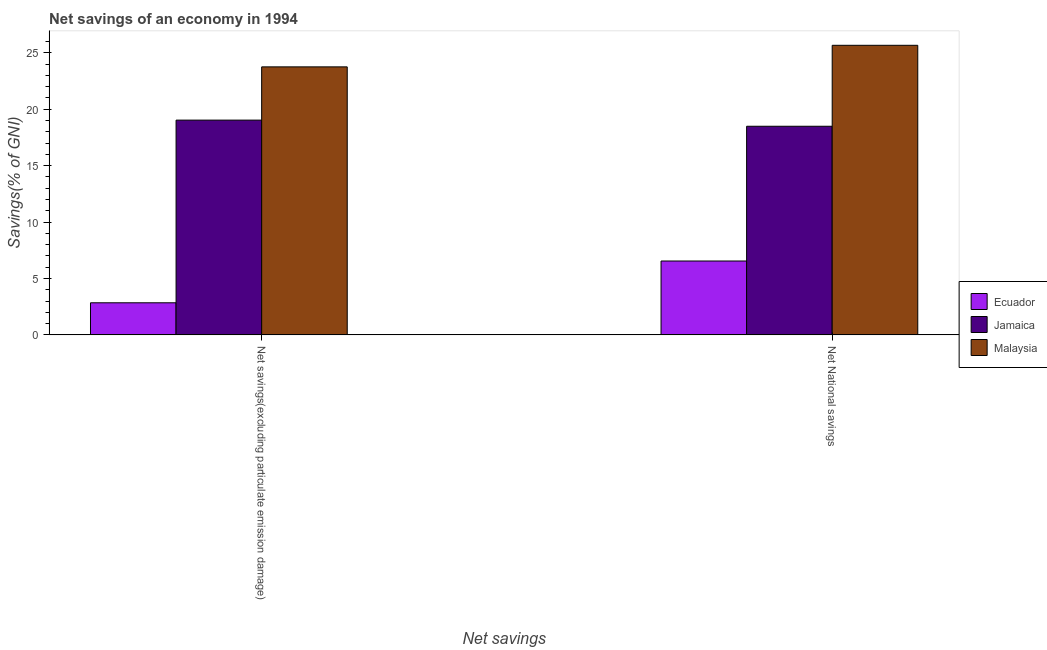How many bars are there on the 1st tick from the right?
Ensure brevity in your answer.  3. What is the label of the 1st group of bars from the left?
Your answer should be very brief. Net savings(excluding particulate emission damage). What is the net savings(excluding particulate emission damage) in Malaysia?
Make the answer very short. 23.76. Across all countries, what is the maximum net savings(excluding particulate emission damage)?
Keep it short and to the point. 23.76. Across all countries, what is the minimum net national savings?
Make the answer very short. 6.55. In which country was the net savings(excluding particulate emission damage) maximum?
Your response must be concise. Malaysia. In which country was the net savings(excluding particulate emission damage) minimum?
Keep it short and to the point. Ecuador. What is the total net national savings in the graph?
Offer a terse response. 50.71. What is the difference between the net savings(excluding particulate emission damage) in Ecuador and that in Malaysia?
Keep it short and to the point. -20.91. What is the difference between the net savings(excluding particulate emission damage) in Ecuador and the net national savings in Jamaica?
Provide a succinct answer. -15.65. What is the average net savings(excluding particulate emission damage) per country?
Offer a very short reply. 15.21. What is the difference between the net savings(excluding particulate emission damage) and net national savings in Ecuador?
Give a very brief answer. -3.7. In how many countries, is the net savings(excluding particulate emission damage) greater than 15 %?
Keep it short and to the point. 2. What is the ratio of the net savings(excluding particulate emission damage) in Jamaica to that in Malaysia?
Your response must be concise. 0.8. In how many countries, is the net savings(excluding particulate emission damage) greater than the average net savings(excluding particulate emission damage) taken over all countries?
Your response must be concise. 2. What does the 2nd bar from the left in Net National savings represents?
Make the answer very short. Jamaica. What does the 1st bar from the right in Net savings(excluding particulate emission damage) represents?
Make the answer very short. Malaysia. How many bars are there?
Your answer should be compact. 6. How many countries are there in the graph?
Your answer should be compact. 3. What is the difference between two consecutive major ticks on the Y-axis?
Offer a terse response. 5. How many legend labels are there?
Give a very brief answer. 3. What is the title of the graph?
Offer a terse response. Net savings of an economy in 1994. What is the label or title of the X-axis?
Offer a very short reply. Net savings. What is the label or title of the Y-axis?
Your answer should be compact. Savings(% of GNI). What is the Savings(% of GNI) in Ecuador in Net savings(excluding particulate emission damage)?
Provide a short and direct response. 2.84. What is the Savings(% of GNI) in Jamaica in Net savings(excluding particulate emission damage)?
Your answer should be very brief. 19.04. What is the Savings(% of GNI) of Malaysia in Net savings(excluding particulate emission damage)?
Your answer should be very brief. 23.76. What is the Savings(% of GNI) in Ecuador in Net National savings?
Give a very brief answer. 6.55. What is the Savings(% of GNI) of Jamaica in Net National savings?
Offer a very short reply. 18.49. What is the Savings(% of GNI) in Malaysia in Net National savings?
Give a very brief answer. 25.67. Across all Net savings, what is the maximum Savings(% of GNI) in Ecuador?
Your response must be concise. 6.55. Across all Net savings, what is the maximum Savings(% of GNI) of Jamaica?
Offer a very short reply. 19.04. Across all Net savings, what is the maximum Savings(% of GNI) in Malaysia?
Offer a terse response. 25.67. Across all Net savings, what is the minimum Savings(% of GNI) of Ecuador?
Offer a terse response. 2.84. Across all Net savings, what is the minimum Savings(% of GNI) of Jamaica?
Provide a succinct answer. 18.49. Across all Net savings, what is the minimum Savings(% of GNI) of Malaysia?
Your answer should be very brief. 23.76. What is the total Savings(% of GNI) of Ecuador in the graph?
Offer a very short reply. 9.39. What is the total Savings(% of GNI) of Jamaica in the graph?
Your response must be concise. 37.53. What is the total Savings(% of GNI) of Malaysia in the graph?
Ensure brevity in your answer.  49.42. What is the difference between the Savings(% of GNI) of Ecuador in Net savings(excluding particulate emission damage) and that in Net National savings?
Your response must be concise. -3.7. What is the difference between the Savings(% of GNI) in Jamaica in Net savings(excluding particulate emission damage) and that in Net National savings?
Give a very brief answer. 0.54. What is the difference between the Savings(% of GNI) in Malaysia in Net savings(excluding particulate emission damage) and that in Net National savings?
Make the answer very short. -1.91. What is the difference between the Savings(% of GNI) of Ecuador in Net savings(excluding particulate emission damage) and the Savings(% of GNI) of Jamaica in Net National savings?
Your answer should be compact. -15.65. What is the difference between the Savings(% of GNI) in Ecuador in Net savings(excluding particulate emission damage) and the Savings(% of GNI) in Malaysia in Net National savings?
Your answer should be very brief. -22.82. What is the difference between the Savings(% of GNI) in Jamaica in Net savings(excluding particulate emission damage) and the Savings(% of GNI) in Malaysia in Net National savings?
Your response must be concise. -6.63. What is the average Savings(% of GNI) in Ecuador per Net savings?
Your response must be concise. 4.7. What is the average Savings(% of GNI) in Jamaica per Net savings?
Provide a succinct answer. 18.76. What is the average Savings(% of GNI) in Malaysia per Net savings?
Provide a short and direct response. 24.71. What is the difference between the Savings(% of GNI) in Ecuador and Savings(% of GNI) in Jamaica in Net savings(excluding particulate emission damage)?
Provide a short and direct response. -16.19. What is the difference between the Savings(% of GNI) of Ecuador and Savings(% of GNI) of Malaysia in Net savings(excluding particulate emission damage)?
Your response must be concise. -20.91. What is the difference between the Savings(% of GNI) in Jamaica and Savings(% of GNI) in Malaysia in Net savings(excluding particulate emission damage)?
Keep it short and to the point. -4.72. What is the difference between the Savings(% of GNI) of Ecuador and Savings(% of GNI) of Jamaica in Net National savings?
Make the answer very short. -11.94. What is the difference between the Savings(% of GNI) in Ecuador and Savings(% of GNI) in Malaysia in Net National savings?
Give a very brief answer. -19.12. What is the difference between the Savings(% of GNI) in Jamaica and Savings(% of GNI) in Malaysia in Net National savings?
Provide a short and direct response. -7.17. What is the ratio of the Savings(% of GNI) of Ecuador in Net savings(excluding particulate emission damage) to that in Net National savings?
Your answer should be compact. 0.43. What is the ratio of the Savings(% of GNI) in Jamaica in Net savings(excluding particulate emission damage) to that in Net National savings?
Your answer should be compact. 1.03. What is the ratio of the Savings(% of GNI) of Malaysia in Net savings(excluding particulate emission damage) to that in Net National savings?
Give a very brief answer. 0.93. What is the difference between the highest and the second highest Savings(% of GNI) in Ecuador?
Ensure brevity in your answer.  3.7. What is the difference between the highest and the second highest Savings(% of GNI) of Jamaica?
Your answer should be very brief. 0.54. What is the difference between the highest and the second highest Savings(% of GNI) in Malaysia?
Provide a succinct answer. 1.91. What is the difference between the highest and the lowest Savings(% of GNI) of Ecuador?
Offer a terse response. 3.7. What is the difference between the highest and the lowest Savings(% of GNI) in Jamaica?
Your answer should be very brief. 0.54. What is the difference between the highest and the lowest Savings(% of GNI) in Malaysia?
Offer a terse response. 1.91. 